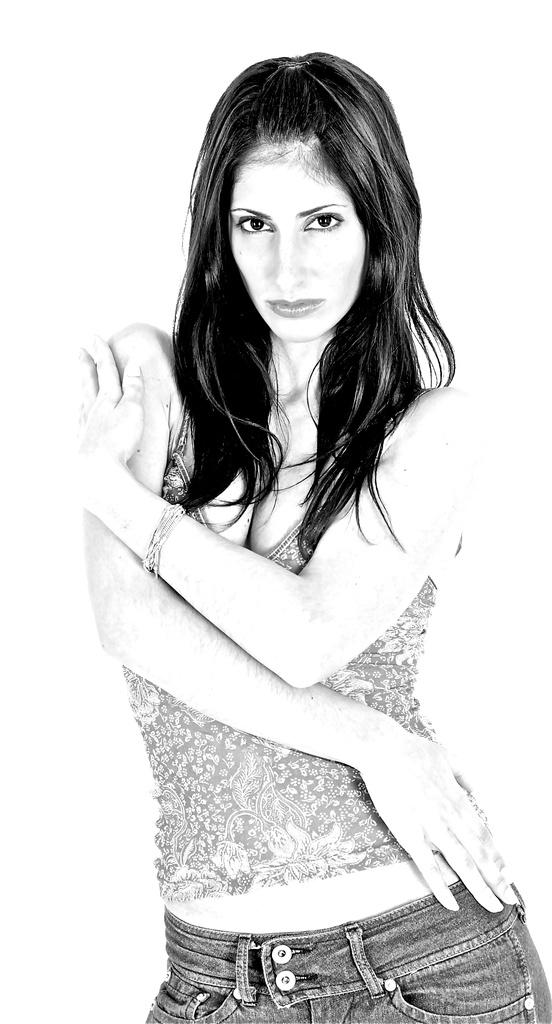Who is present in the image? There is a woman in the image. What is the woman doing in the image? The woman is standing and watching. What type of grass is visible in the image? There is no grass visible in the image; it features a woman standing and watching. 